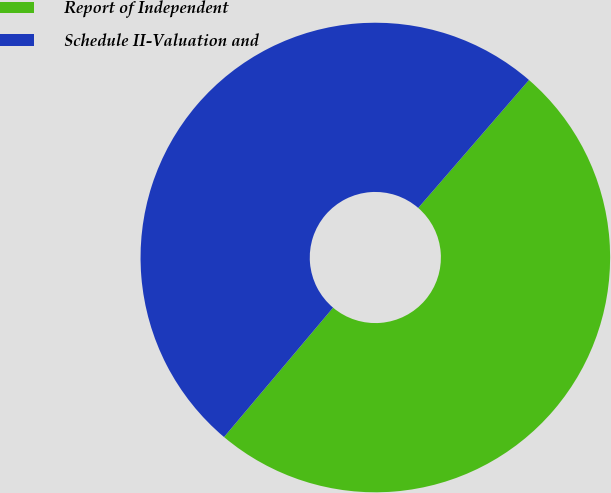Convert chart. <chart><loc_0><loc_0><loc_500><loc_500><pie_chart><fcel>Report of Independent<fcel>Schedule II-Valuation and<nl><fcel>49.79%<fcel>50.21%<nl></chart> 